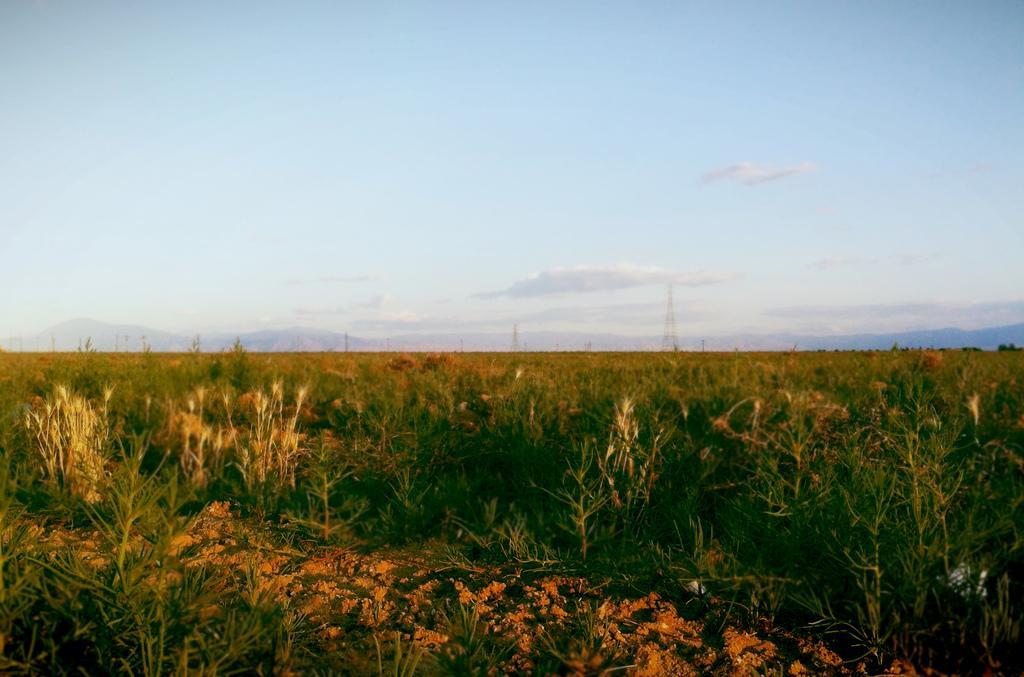In one or two sentences, can you explain what this image depicts? There is a path. On both sides of this path, there are plants. In the background, there are towers, mountains and clouds in the blue sky. 